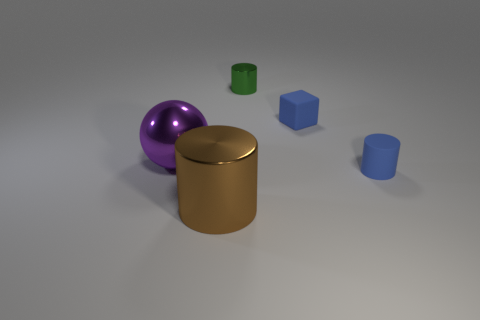What material is the tiny cylinder that is right of the small green thing?
Offer a terse response. Rubber. Is there any other thing that has the same size as the blue block?
Ensure brevity in your answer.  Yes. Are there any big cylinders in front of the brown cylinder?
Offer a terse response. No. There is a brown metallic object; what shape is it?
Your response must be concise. Cylinder. How many objects are blue objects that are in front of the purple sphere or tiny objects?
Make the answer very short. 3. How many other things are the same color as the large sphere?
Ensure brevity in your answer.  0. Do the big sphere and the shiny object that is on the right side of the big metallic cylinder have the same color?
Keep it short and to the point. No. What is the color of the other metal object that is the same shape as the green metal thing?
Offer a very short reply. Brown. Is the material of the ball the same as the tiny cylinder that is in front of the small metallic object?
Offer a terse response. No. The big cylinder has what color?
Provide a succinct answer. Brown. 